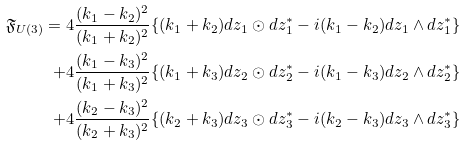<formula> <loc_0><loc_0><loc_500><loc_500>\mathfrak { F } _ { U ( 3 ) } = 4 \frac { ( k _ { 1 } - k _ { 2 } ) ^ { 2 } } { ( k _ { 1 } + k _ { 2 } ) ^ { 2 } } & \{ ( k _ { 1 } + k _ { 2 } ) d z _ { 1 } \odot d z _ { 1 } ^ { * } - i ( k _ { 1 } - k _ { 2 } ) d z _ { 1 } \wedge d z _ { 1 } ^ { * } \} \\ + 4 \frac { ( k _ { 1 } - k _ { 3 } ) ^ { 2 } } { ( k _ { 1 } + k _ { 3 } ) ^ { 2 } } & \{ ( k _ { 1 } + k _ { 3 } ) d z _ { 2 } \odot d z _ { 2 } ^ { * } - i ( k _ { 1 } - k _ { 3 } ) d z _ { 2 } \wedge d z _ { 2 } ^ { * } \} \\ + 4 \frac { ( k _ { 2 } - k _ { 3 } ) ^ { 2 } } { ( k _ { 2 } + k _ { 3 } ) ^ { 2 } } & \{ ( k _ { 2 } + k _ { 3 } ) d z _ { 3 } \odot d z _ { 3 } ^ { * } - i ( k _ { 2 } - k _ { 3 } ) d z _ { 3 } \wedge d z _ { 3 } ^ { * } \} \\</formula> 